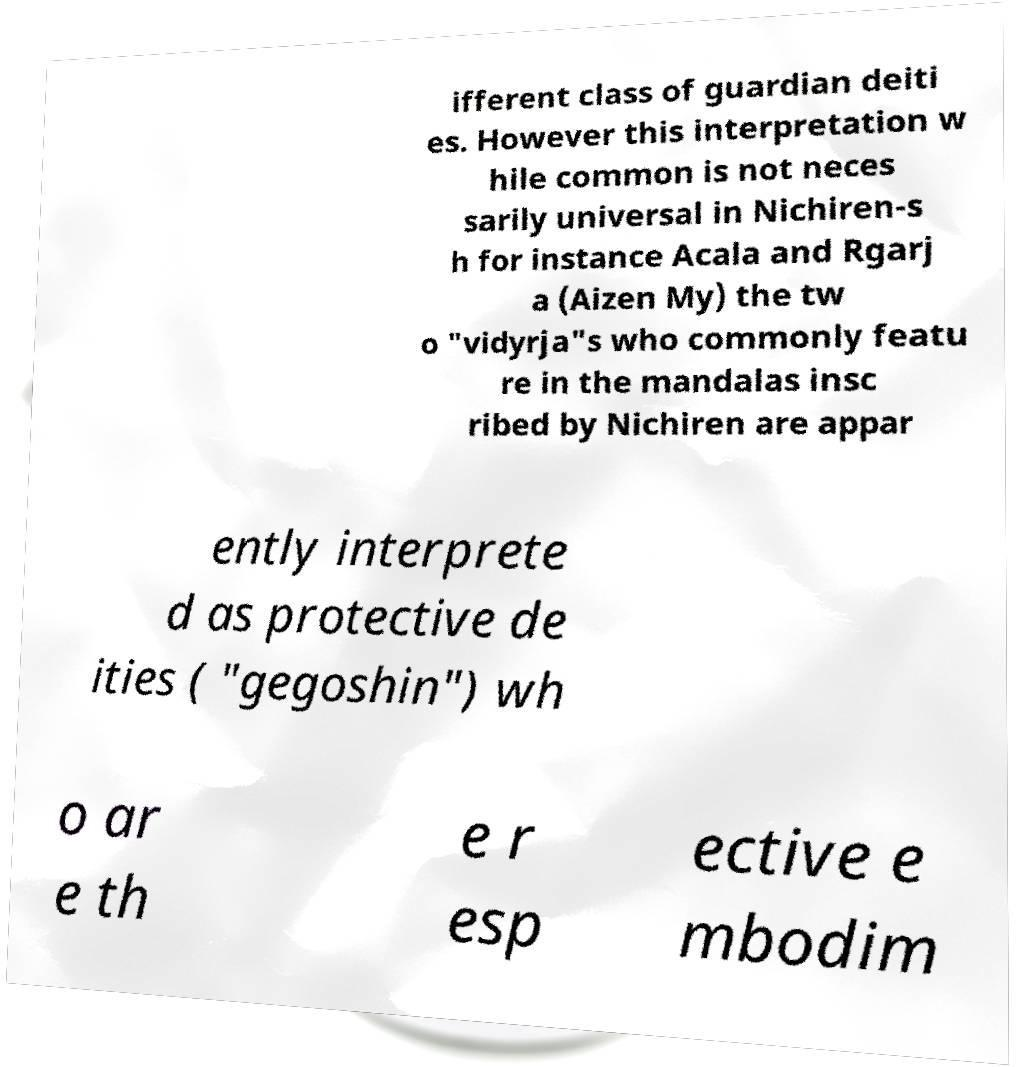For documentation purposes, I need the text within this image transcribed. Could you provide that? ifferent class of guardian deiti es. However this interpretation w hile common is not neces sarily universal in Nichiren-s h for instance Acala and Rgarj a (Aizen My) the tw o "vidyrja"s who commonly featu re in the mandalas insc ribed by Nichiren are appar ently interprete d as protective de ities ( "gegoshin") wh o ar e th e r esp ective e mbodim 